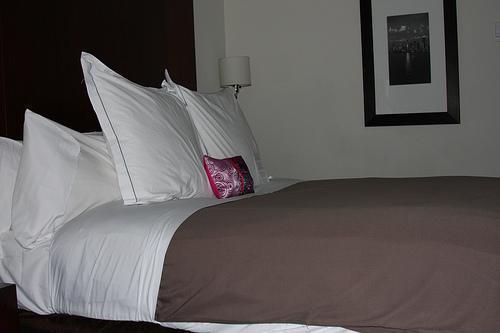How many beds are pictured?
Give a very brief answer. 1. How many pictures are on the wall?
Give a very brief answer. 1. 